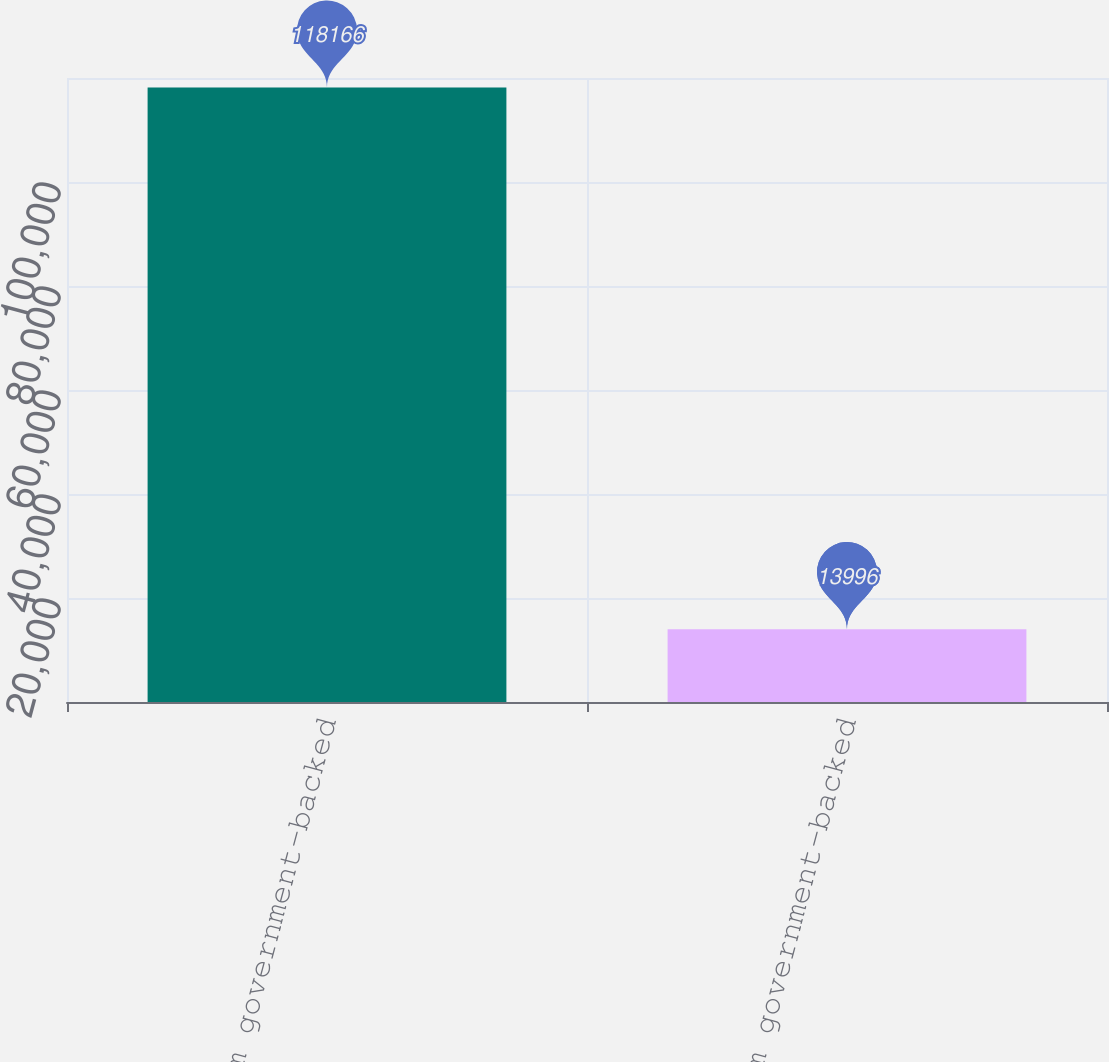Convert chart. <chart><loc_0><loc_0><loc_500><loc_500><bar_chart><fcel>Short-term government-backed<fcel>Long-term government-backed<nl><fcel>118166<fcel>13996<nl></chart> 